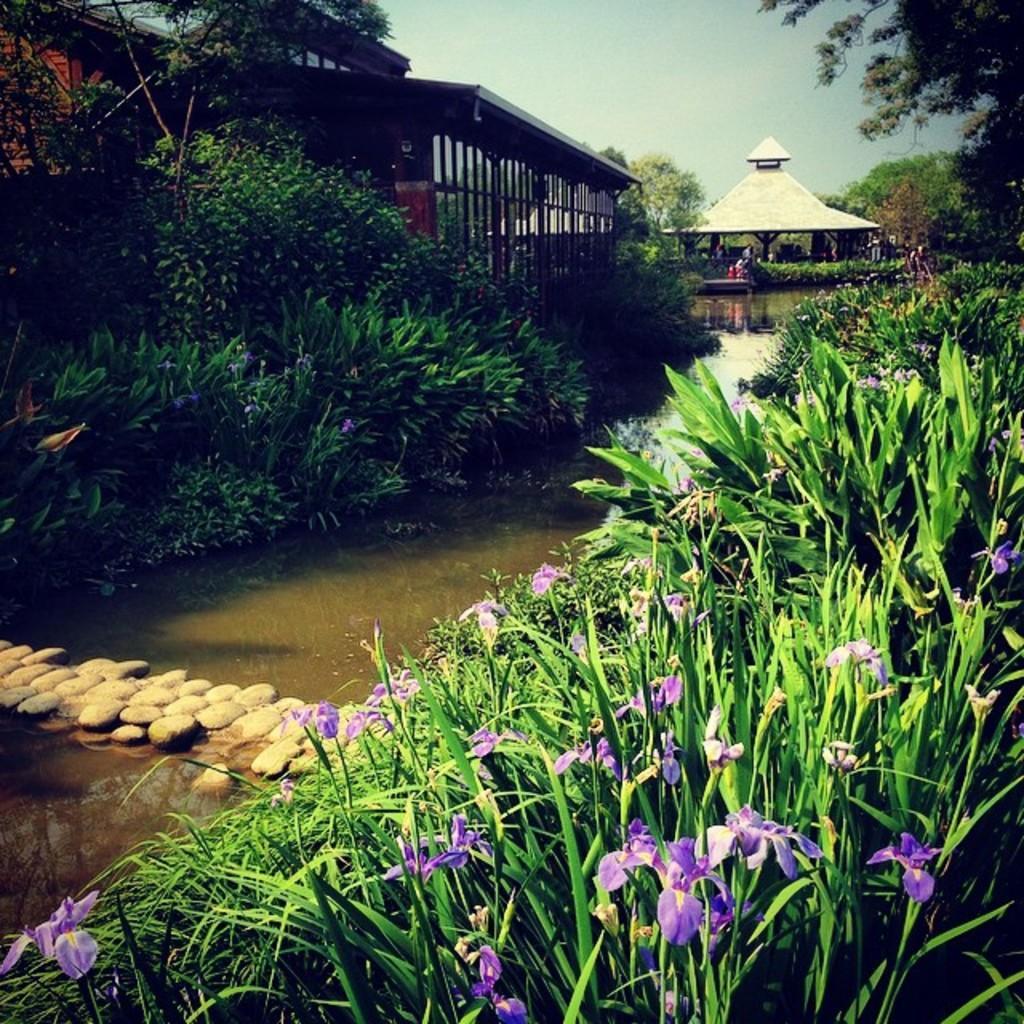How would you summarize this image in a sentence or two? In the picture I can see house beside the house we can see water flow, rocks, flowers to the plants and some trees. 